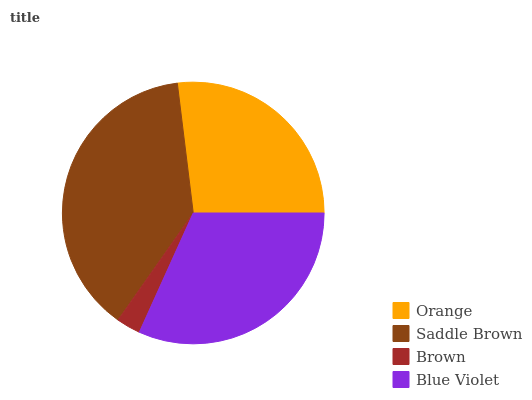Is Brown the minimum?
Answer yes or no. Yes. Is Saddle Brown the maximum?
Answer yes or no. Yes. Is Saddle Brown the minimum?
Answer yes or no. No. Is Brown the maximum?
Answer yes or no. No. Is Saddle Brown greater than Brown?
Answer yes or no. Yes. Is Brown less than Saddle Brown?
Answer yes or no. Yes. Is Brown greater than Saddle Brown?
Answer yes or no. No. Is Saddle Brown less than Brown?
Answer yes or no. No. Is Blue Violet the high median?
Answer yes or no. Yes. Is Orange the low median?
Answer yes or no. Yes. Is Orange the high median?
Answer yes or no. No. Is Saddle Brown the low median?
Answer yes or no. No. 